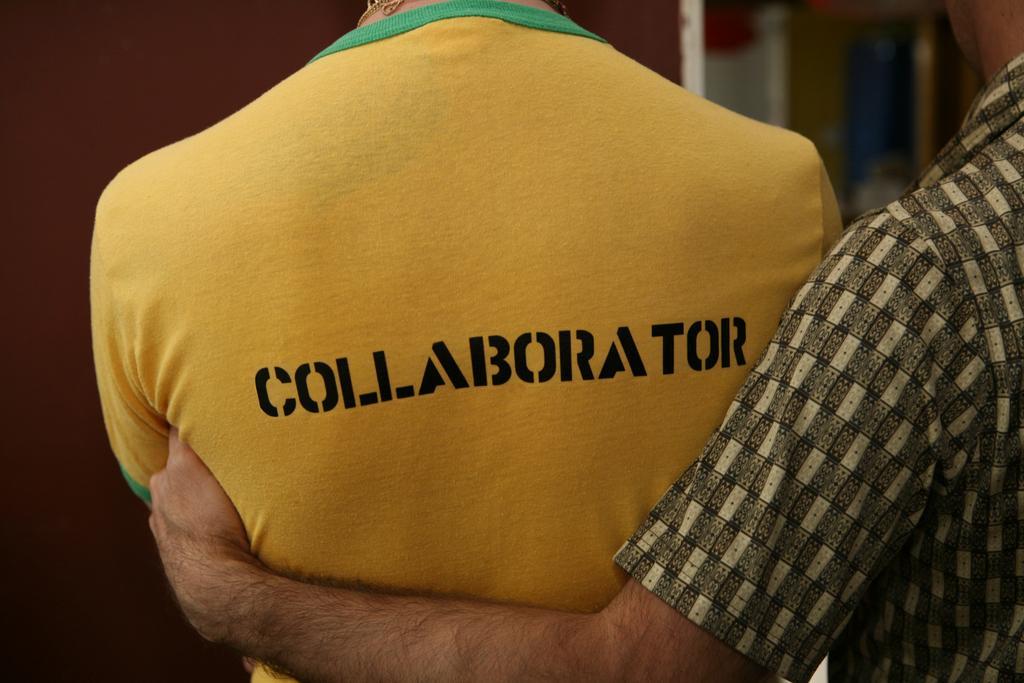Please provide a concise description of this image. On the right side, there is a person in a shirt, holding a person who is in yellow color t-shirt, on which there is a black color text. And the background is blurred. 